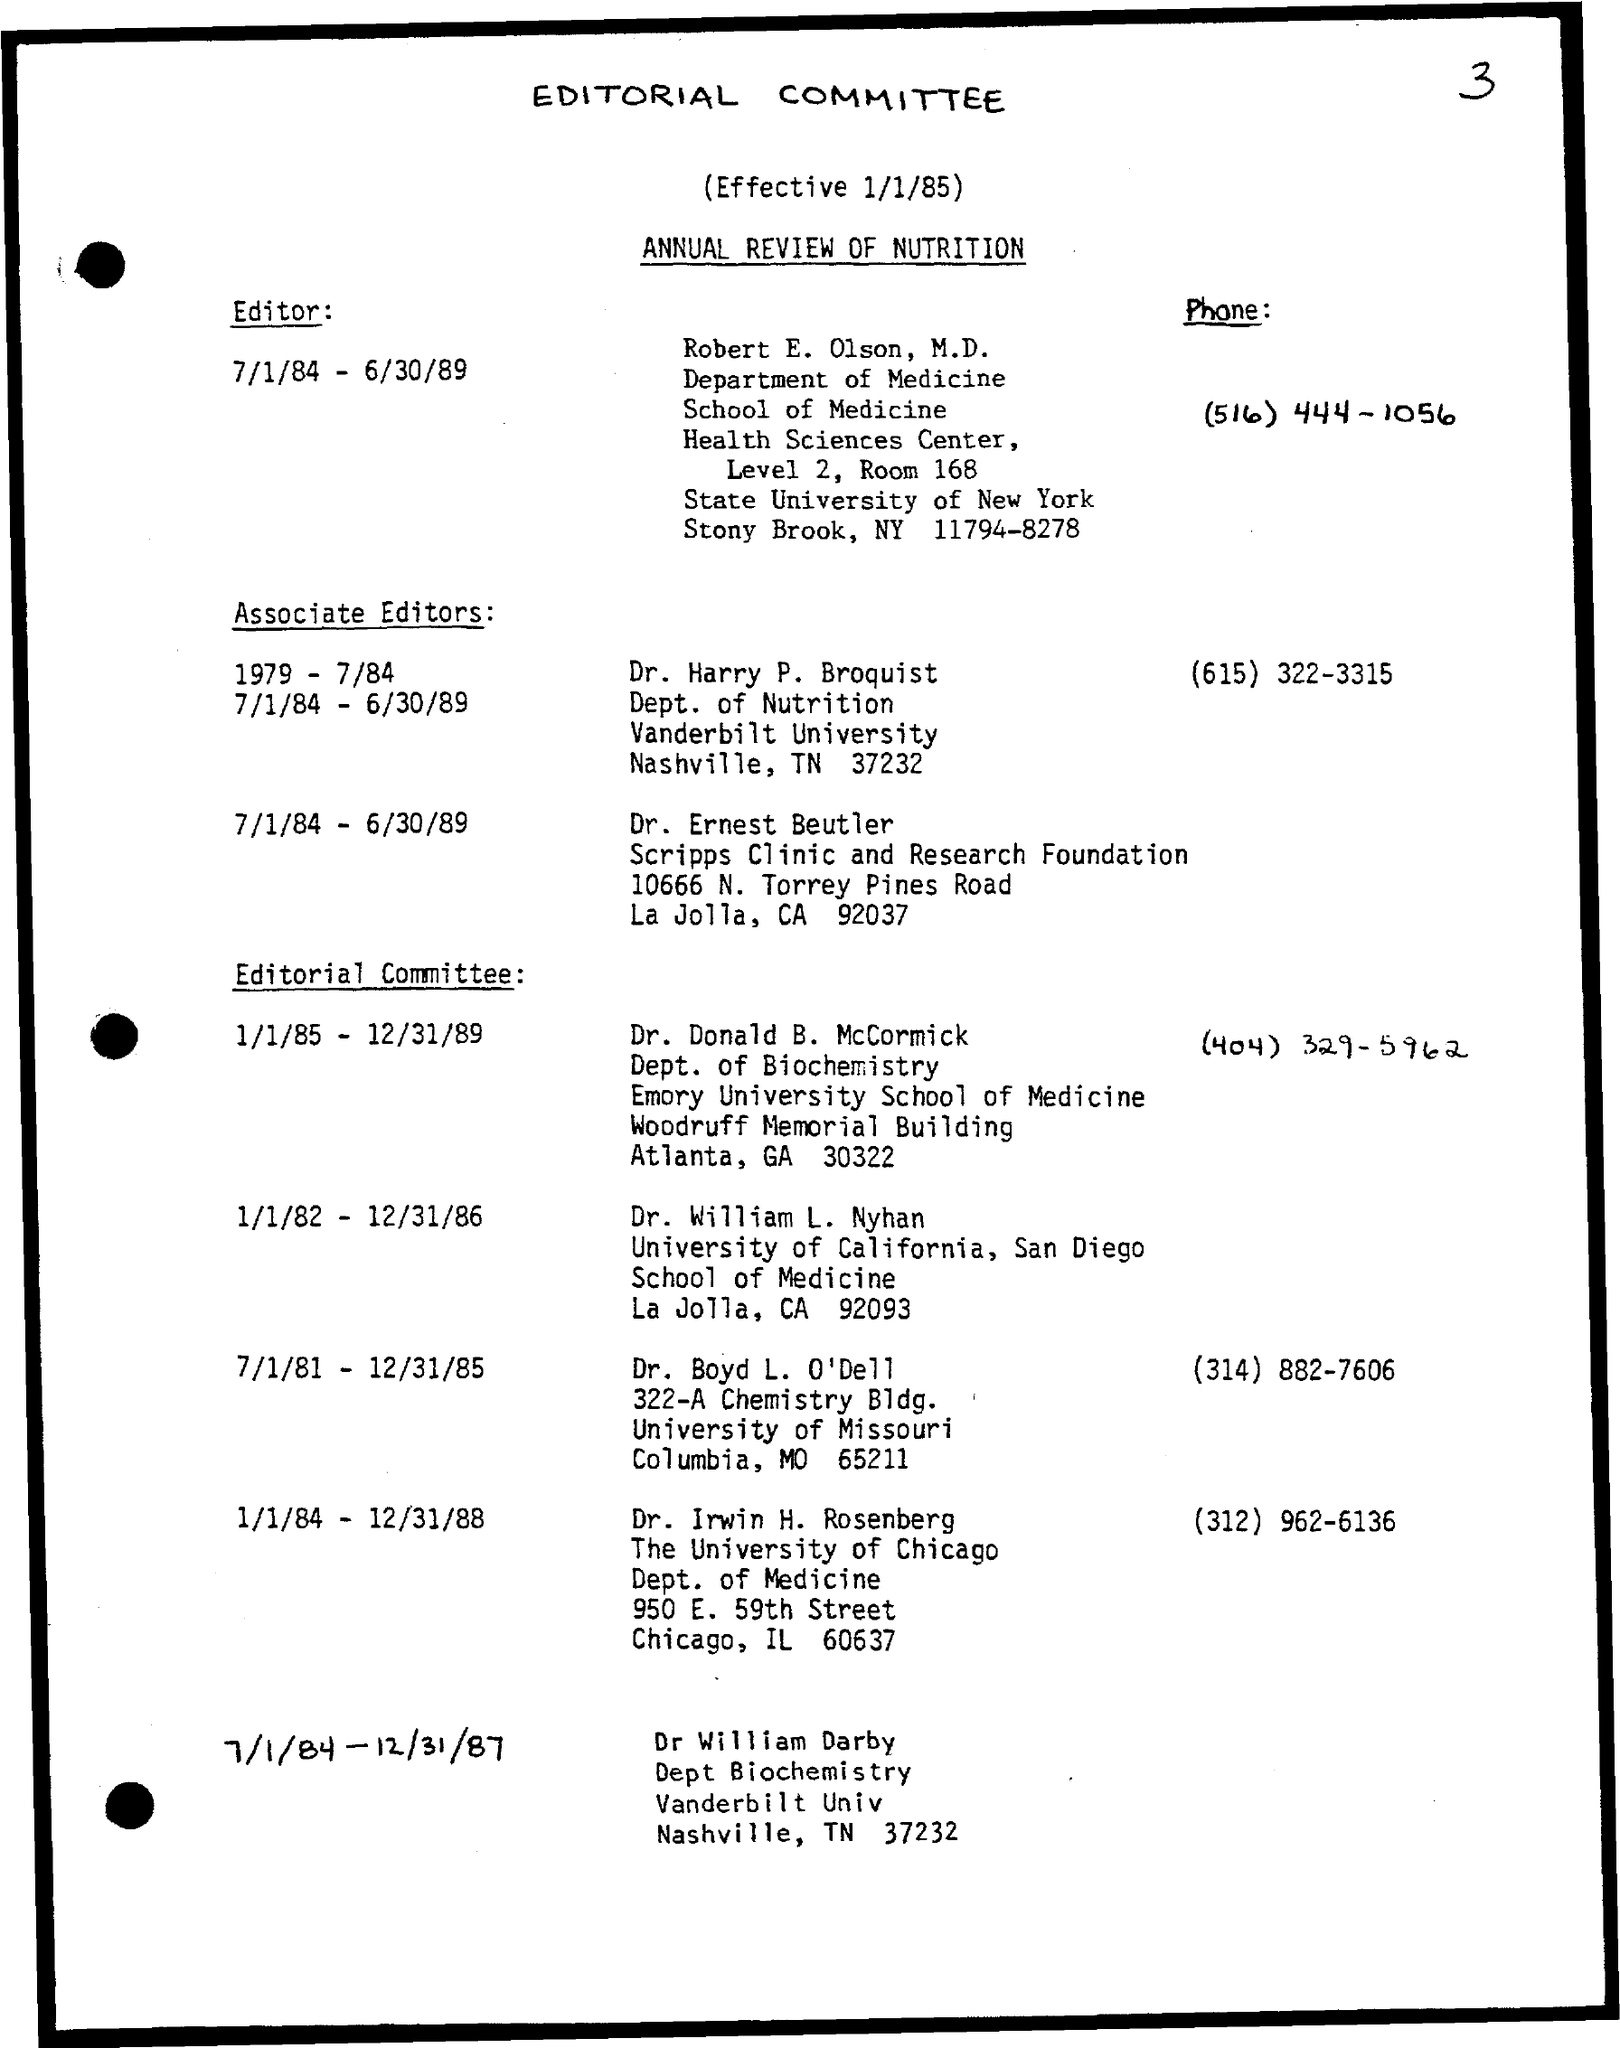When is the committee effective from?
Your answer should be very brief. 1/1/85. What is the document title?
Provide a succinct answer. ANNUAL REVIEW OF NUTRITION. Which committee is mentioned?
Your answer should be very brief. EDITORIAL COMMITTEE. Who is the editor?
Offer a very short reply. Robert E. Olson, M.D. What is the editor's phone number?
Your answer should be very brief. (516) 444-1056. Which department is Dr. Harry Broquist from?
Give a very brief answer. Dept. of Nutrition. Which university is Dr. Donald B. McCormick part of?
Make the answer very short. Emory University School of Medicine. What is the phone number of Dr. Irwin H. Rosenberg?
Ensure brevity in your answer.  (312) 962-6136. 